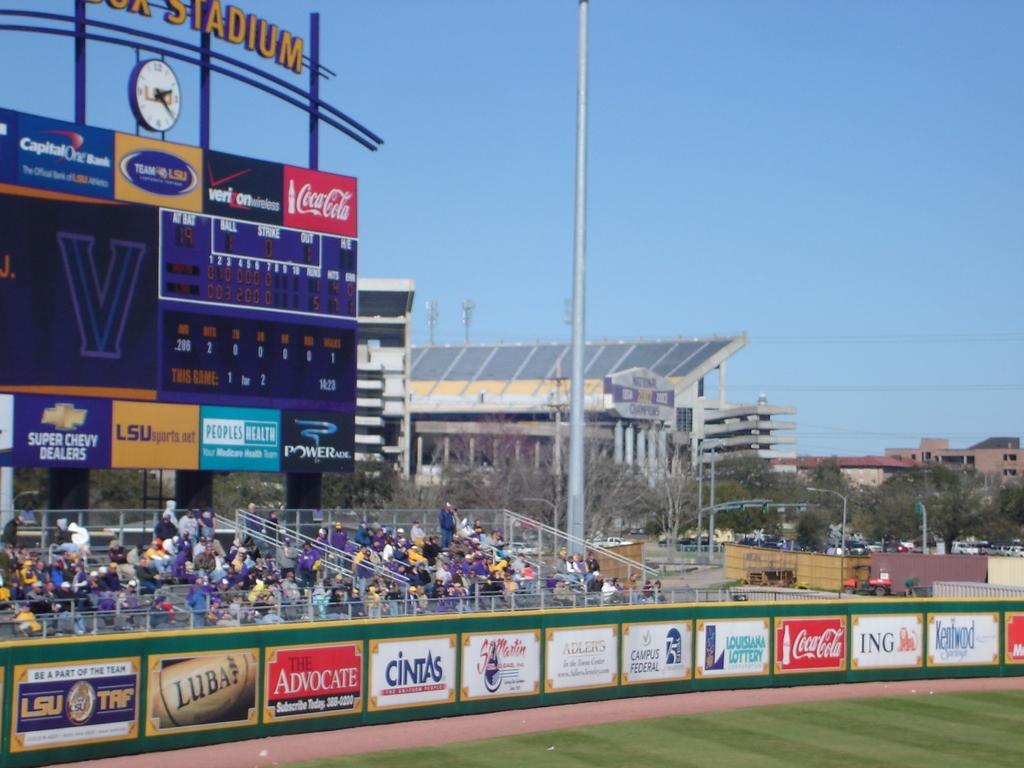Provide a one-sentence caption for the provided image. A baseball field with advertisements like The Advocate and Campus Federal. 